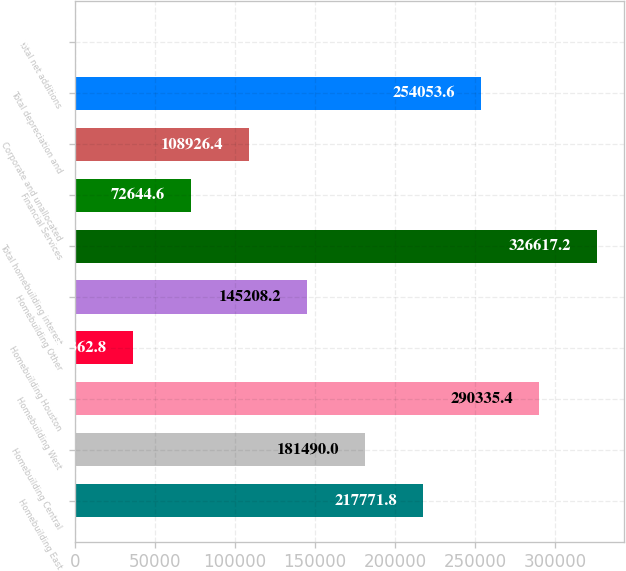<chart> <loc_0><loc_0><loc_500><loc_500><bar_chart><fcel>Homebuilding East<fcel>Homebuilding Central<fcel>Homebuilding West<fcel>Homebuilding Houston<fcel>Homebuilding Other<fcel>Total homebuilding interest<fcel>Financial Services<fcel>Corporate and unallocated<fcel>Total depreciation and<fcel>Total net additions<nl><fcel>217772<fcel>181490<fcel>290335<fcel>36362.8<fcel>145208<fcel>326617<fcel>72644.6<fcel>108926<fcel>254054<fcel>81<nl></chart> 